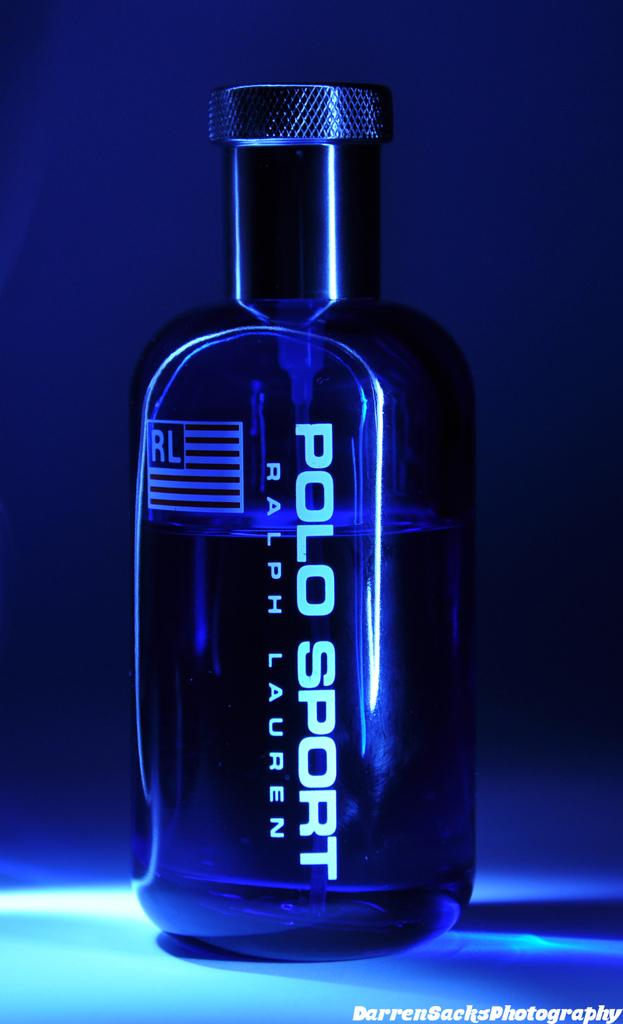<image>
Share a concise interpretation of the image provided. Polo Sport by Ralph Lauren is printed on the side of this bottle. 